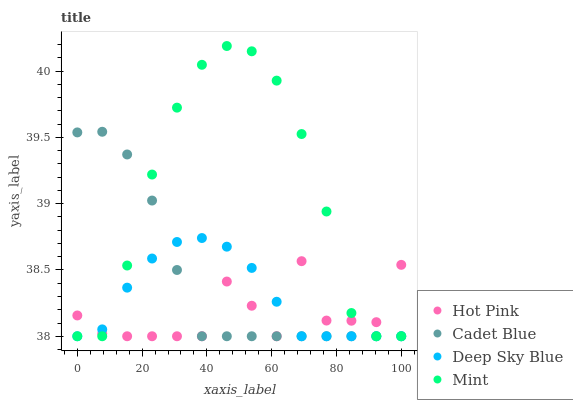Does Hot Pink have the minimum area under the curve?
Answer yes or no. Yes. Does Mint have the maximum area under the curve?
Answer yes or no. Yes. Does Mint have the minimum area under the curve?
Answer yes or no. No. Does Hot Pink have the maximum area under the curve?
Answer yes or no. No. Is Cadet Blue the smoothest?
Answer yes or no. Yes. Is Hot Pink the roughest?
Answer yes or no. Yes. Is Mint the smoothest?
Answer yes or no. No. Is Mint the roughest?
Answer yes or no. No. Does Cadet Blue have the lowest value?
Answer yes or no. Yes. Does Mint have the highest value?
Answer yes or no. Yes. Does Hot Pink have the highest value?
Answer yes or no. No. Does Mint intersect Cadet Blue?
Answer yes or no. Yes. Is Mint less than Cadet Blue?
Answer yes or no. No. Is Mint greater than Cadet Blue?
Answer yes or no. No. 